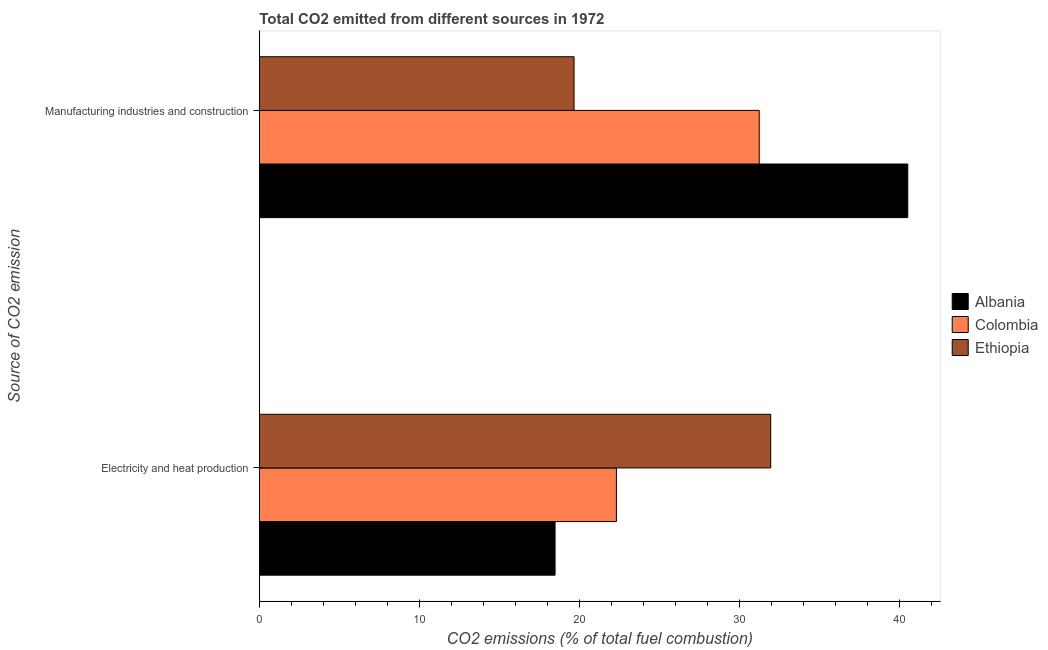How many different coloured bars are there?
Give a very brief answer. 3. How many bars are there on the 2nd tick from the top?
Your answer should be compact. 3. What is the label of the 1st group of bars from the top?
Give a very brief answer. Manufacturing industries and construction. What is the co2 emissions due to manufacturing industries in Albania?
Provide a succinct answer. 40.53. Across all countries, what is the maximum co2 emissions due to electricity and heat production?
Offer a terse response. 31.97. Across all countries, what is the minimum co2 emissions due to electricity and heat production?
Your answer should be very brief. 18.49. In which country was the co2 emissions due to electricity and heat production maximum?
Your answer should be compact. Ethiopia. In which country was the co2 emissions due to manufacturing industries minimum?
Give a very brief answer. Ethiopia. What is the total co2 emissions due to electricity and heat production in the graph?
Provide a short and direct response. 72.77. What is the difference between the co2 emissions due to electricity and heat production in Albania and that in Ethiopia?
Offer a terse response. -13.48. What is the difference between the co2 emissions due to manufacturing industries in Colombia and the co2 emissions due to electricity and heat production in Ethiopia?
Keep it short and to the point. -0.72. What is the average co2 emissions due to manufacturing industries per country?
Offer a very short reply. 30.48. What is the difference between the co2 emissions due to electricity and heat production and co2 emissions due to manufacturing industries in Colombia?
Offer a very short reply. -8.93. In how many countries, is the co2 emissions due to manufacturing industries greater than 34 %?
Offer a very short reply. 1. What is the ratio of the co2 emissions due to manufacturing industries in Ethiopia to that in Colombia?
Offer a very short reply. 0.63. What does the 1st bar from the top in Electricity and heat production represents?
Your answer should be very brief. Ethiopia. What does the 1st bar from the bottom in Manufacturing industries and construction represents?
Provide a succinct answer. Albania. How many bars are there?
Offer a terse response. 6. What is the difference between two consecutive major ticks on the X-axis?
Keep it short and to the point. 10. Does the graph contain any zero values?
Provide a succinct answer. No. What is the title of the graph?
Offer a terse response. Total CO2 emitted from different sources in 1972. What is the label or title of the X-axis?
Offer a terse response. CO2 emissions (% of total fuel combustion). What is the label or title of the Y-axis?
Ensure brevity in your answer.  Source of CO2 emission. What is the CO2 emissions (% of total fuel combustion) in Albania in Electricity and heat production?
Offer a terse response. 18.49. What is the CO2 emissions (% of total fuel combustion) of Colombia in Electricity and heat production?
Make the answer very short. 22.32. What is the CO2 emissions (% of total fuel combustion) of Ethiopia in Electricity and heat production?
Your response must be concise. 31.97. What is the CO2 emissions (% of total fuel combustion) in Albania in Manufacturing industries and construction?
Your answer should be very brief. 40.53. What is the CO2 emissions (% of total fuel combustion) in Colombia in Manufacturing industries and construction?
Your answer should be compact. 31.25. What is the CO2 emissions (% of total fuel combustion) of Ethiopia in Manufacturing industries and construction?
Make the answer very short. 19.67. Across all Source of CO2 emission, what is the maximum CO2 emissions (% of total fuel combustion) in Albania?
Your answer should be very brief. 40.53. Across all Source of CO2 emission, what is the maximum CO2 emissions (% of total fuel combustion) in Colombia?
Your response must be concise. 31.25. Across all Source of CO2 emission, what is the maximum CO2 emissions (% of total fuel combustion) of Ethiopia?
Provide a succinct answer. 31.97. Across all Source of CO2 emission, what is the minimum CO2 emissions (% of total fuel combustion) in Albania?
Ensure brevity in your answer.  18.49. Across all Source of CO2 emission, what is the minimum CO2 emissions (% of total fuel combustion) in Colombia?
Provide a succinct answer. 22.32. Across all Source of CO2 emission, what is the minimum CO2 emissions (% of total fuel combustion) in Ethiopia?
Your answer should be very brief. 19.67. What is the total CO2 emissions (% of total fuel combustion) of Albania in the graph?
Provide a short and direct response. 59.02. What is the total CO2 emissions (% of total fuel combustion) of Colombia in the graph?
Make the answer very short. 53.57. What is the total CO2 emissions (% of total fuel combustion) in Ethiopia in the graph?
Provide a succinct answer. 51.64. What is the difference between the CO2 emissions (% of total fuel combustion) in Albania in Electricity and heat production and that in Manufacturing industries and construction?
Offer a very short reply. -22.05. What is the difference between the CO2 emissions (% of total fuel combustion) in Colombia in Electricity and heat production and that in Manufacturing industries and construction?
Your answer should be very brief. -8.93. What is the difference between the CO2 emissions (% of total fuel combustion) in Ethiopia in Electricity and heat production and that in Manufacturing industries and construction?
Your answer should be very brief. 12.3. What is the difference between the CO2 emissions (% of total fuel combustion) of Albania in Electricity and heat production and the CO2 emissions (% of total fuel combustion) of Colombia in Manufacturing industries and construction?
Your answer should be very brief. -12.76. What is the difference between the CO2 emissions (% of total fuel combustion) in Albania in Electricity and heat production and the CO2 emissions (% of total fuel combustion) in Ethiopia in Manufacturing industries and construction?
Make the answer very short. -1.19. What is the difference between the CO2 emissions (% of total fuel combustion) of Colombia in Electricity and heat production and the CO2 emissions (% of total fuel combustion) of Ethiopia in Manufacturing industries and construction?
Your response must be concise. 2.65. What is the average CO2 emissions (% of total fuel combustion) in Albania per Source of CO2 emission?
Offer a terse response. 29.51. What is the average CO2 emissions (% of total fuel combustion) in Colombia per Source of CO2 emission?
Keep it short and to the point. 26.78. What is the average CO2 emissions (% of total fuel combustion) in Ethiopia per Source of CO2 emission?
Keep it short and to the point. 25.82. What is the difference between the CO2 emissions (% of total fuel combustion) of Albania and CO2 emissions (% of total fuel combustion) of Colombia in Electricity and heat production?
Your response must be concise. -3.83. What is the difference between the CO2 emissions (% of total fuel combustion) in Albania and CO2 emissions (% of total fuel combustion) in Ethiopia in Electricity and heat production?
Offer a very short reply. -13.48. What is the difference between the CO2 emissions (% of total fuel combustion) of Colombia and CO2 emissions (% of total fuel combustion) of Ethiopia in Electricity and heat production?
Your answer should be very brief. -9.65. What is the difference between the CO2 emissions (% of total fuel combustion) of Albania and CO2 emissions (% of total fuel combustion) of Colombia in Manufacturing industries and construction?
Keep it short and to the point. 9.29. What is the difference between the CO2 emissions (% of total fuel combustion) of Albania and CO2 emissions (% of total fuel combustion) of Ethiopia in Manufacturing industries and construction?
Offer a terse response. 20.86. What is the difference between the CO2 emissions (% of total fuel combustion) in Colombia and CO2 emissions (% of total fuel combustion) in Ethiopia in Manufacturing industries and construction?
Keep it short and to the point. 11.58. What is the ratio of the CO2 emissions (% of total fuel combustion) in Albania in Electricity and heat production to that in Manufacturing industries and construction?
Your response must be concise. 0.46. What is the ratio of the CO2 emissions (% of total fuel combustion) of Ethiopia in Electricity and heat production to that in Manufacturing industries and construction?
Provide a succinct answer. 1.62. What is the difference between the highest and the second highest CO2 emissions (% of total fuel combustion) of Albania?
Your answer should be compact. 22.05. What is the difference between the highest and the second highest CO2 emissions (% of total fuel combustion) of Colombia?
Offer a terse response. 8.93. What is the difference between the highest and the second highest CO2 emissions (% of total fuel combustion) of Ethiopia?
Your answer should be very brief. 12.3. What is the difference between the highest and the lowest CO2 emissions (% of total fuel combustion) of Albania?
Give a very brief answer. 22.05. What is the difference between the highest and the lowest CO2 emissions (% of total fuel combustion) of Colombia?
Provide a succinct answer. 8.93. What is the difference between the highest and the lowest CO2 emissions (% of total fuel combustion) in Ethiopia?
Provide a short and direct response. 12.3. 